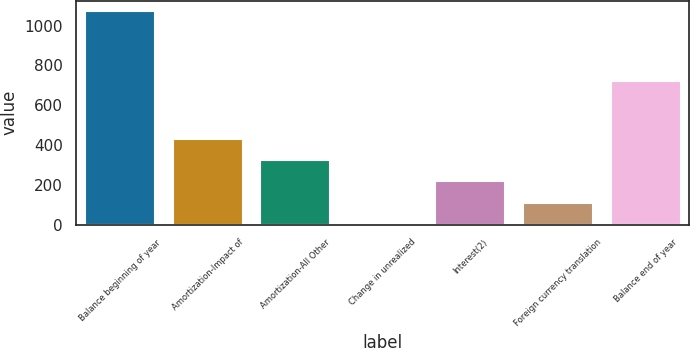Convert chart. <chart><loc_0><loc_0><loc_500><loc_500><bar_chart><fcel>Balance beginning of year<fcel>Amortization-Impact of<fcel>Amortization-All Other<fcel>Change in unrealized<fcel>Interest(2)<fcel>Foreign currency translation<fcel>Balance end of year<nl><fcel>1072<fcel>430.6<fcel>323.7<fcel>3<fcel>216.8<fcel>109.9<fcel>719<nl></chart> 